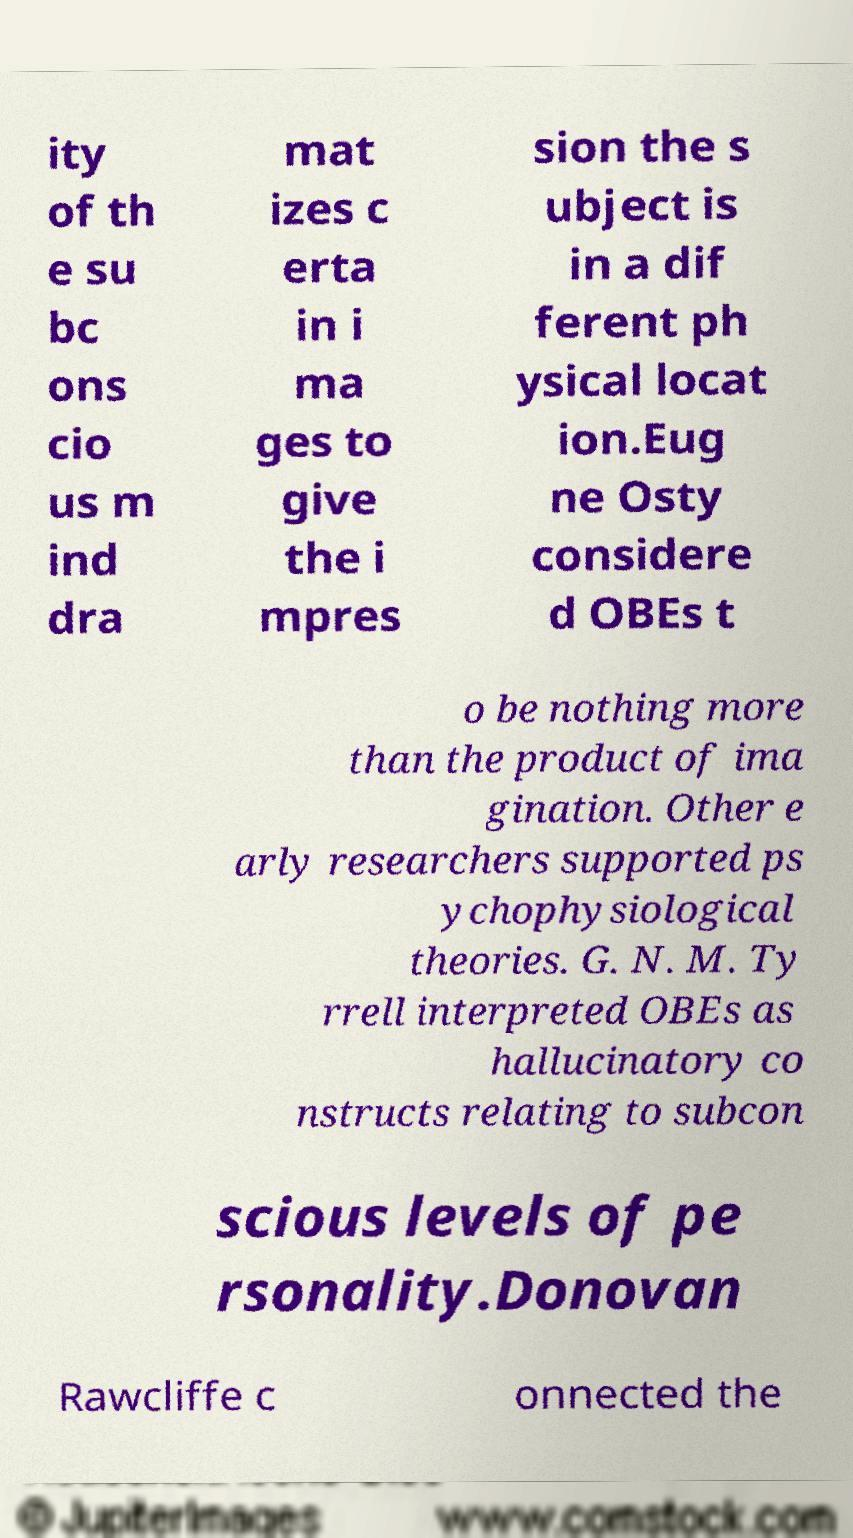What messages or text are displayed in this image? I need them in a readable, typed format. ity of th e su bc ons cio us m ind dra mat izes c erta in i ma ges to give the i mpres sion the s ubject is in a dif ferent ph ysical locat ion.Eug ne Osty considere d OBEs t o be nothing more than the product of ima gination. Other e arly researchers supported ps ychophysiological theories. G. N. M. Ty rrell interpreted OBEs as hallucinatory co nstructs relating to subcon scious levels of pe rsonality.Donovan Rawcliffe c onnected the 